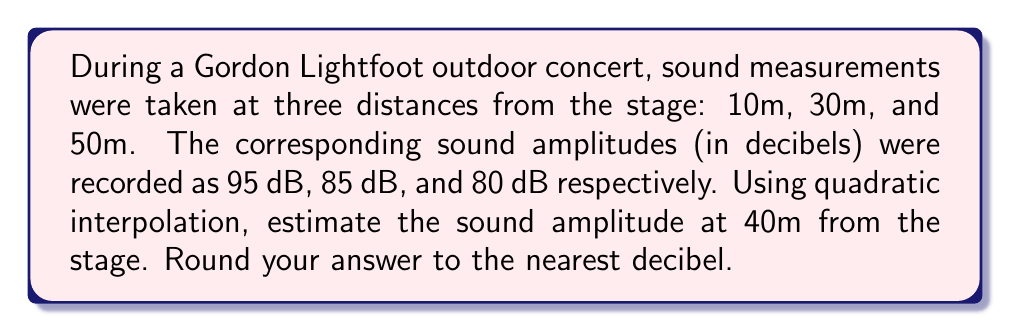Give your solution to this math problem. To solve this problem, we'll use quadratic interpolation with the given data points. Let's follow these steps:

1) First, we need to set up our quadratic interpolation formula:
   $$f(x) = a_0 + a_1(x-x_0) + a_2(x-x_0)(x-x_1)$$

2) We have three data points:
   $(x_0, y_0) = (10, 95)$
   $(x_1, y_1) = (30, 85)$
   $(x_2, y_2) = (50, 80)$

3) Now, we can calculate the coefficients $a_0$, $a_1$, and $a_2$:

   $a_0 = y_0 = 95$

   $a_1 = \frac{y_1 - y_0}{x_1 - x_0} = \frac{85 - 95}{30 - 10} = -0.5$

   $a_2 = \frac{\frac{y_2 - y_1}{x_2 - x_1} - \frac{y_1 - y_0}{x_1 - x_0}}{x_2 - x_0}$
        $= \frac{\frac{80 - 85}{50 - 30} - \frac{85 - 95}{30 - 10}}{50 - 10}$
        $= \frac{-0.25 - (-0.5)}{40} = 0.00625$

4) Our interpolation formula becomes:
   $$f(x) = 95 - 0.5(x-10) + 0.00625(x-10)(x-30)$$

5) To estimate the sound amplitude at 40m, we substitute $x = 40$:
   $$f(40) = 95 - 0.5(40-10) + 0.00625(40-10)(40-30)$$
   $$= 95 - 15 + 0.00625(30)(10)$$
   $$= 80 + 1.875 = 81.875$$

6) Rounding to the nearest decibel: 82 dB
Answer: 82 dB 